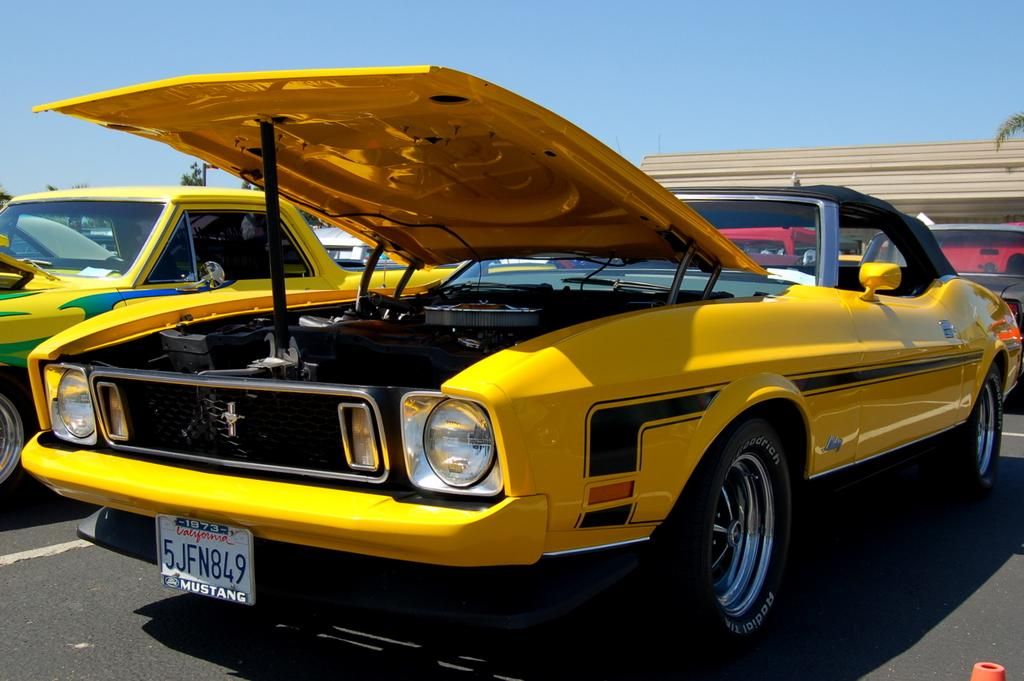<image>
Summarize the visual content of the image. A sports car parked with the hood up with a license plate of 5JFN849. 